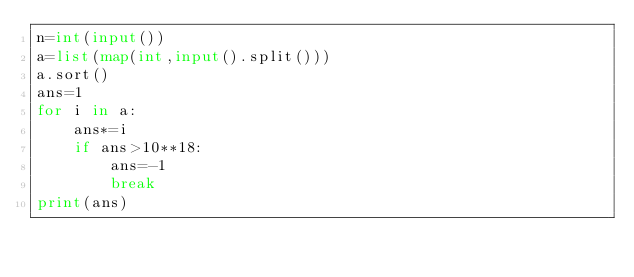<code> <loc_0><loc_0><loc_500><loc_500><_Python_>n=int(input())
a=list(map(int,input().split()))
a.sort()
ans=1
for i in a:
    ans*=i
    if ans>10**18:
        ans=-1
        break
print(ans)</code> 